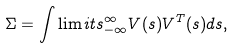Convert formula to latex. <formula><loc_0><loc_0><loc_500><loc_500>\Sigma = \int \lim i t s _ { - \infty } ^ { \infty } V ( s ) V ^ { T } ( s ) d s ,</formula> 